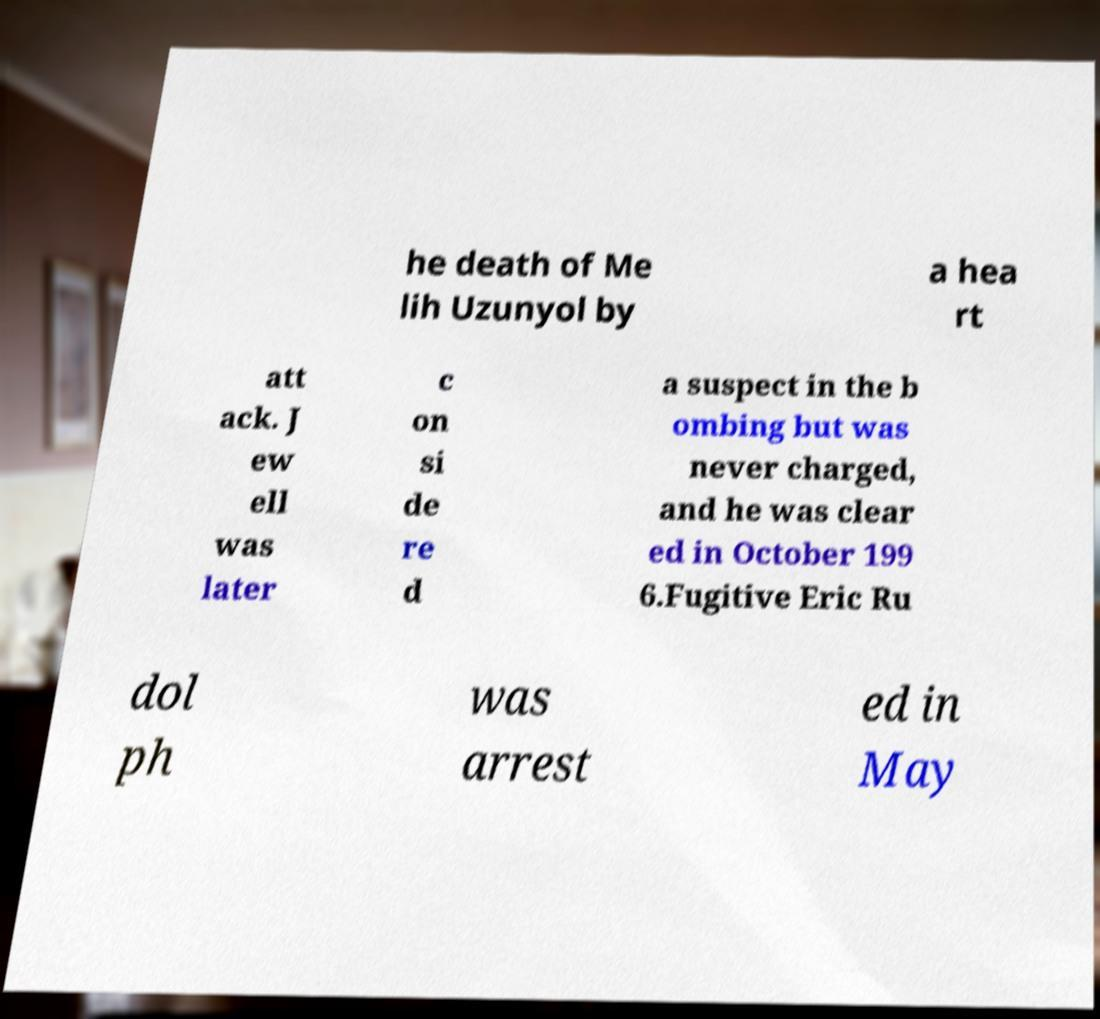Please identify and transcribe the text found in this image. he death of Me lih Uzunyol by a hea rt att ack. J ew ell was later c on si de re d a suspect in the b ombing but was never charged, and he was clear ed in October 199 6.Fugitive Eric Ru dol ph was arrest ed in May 